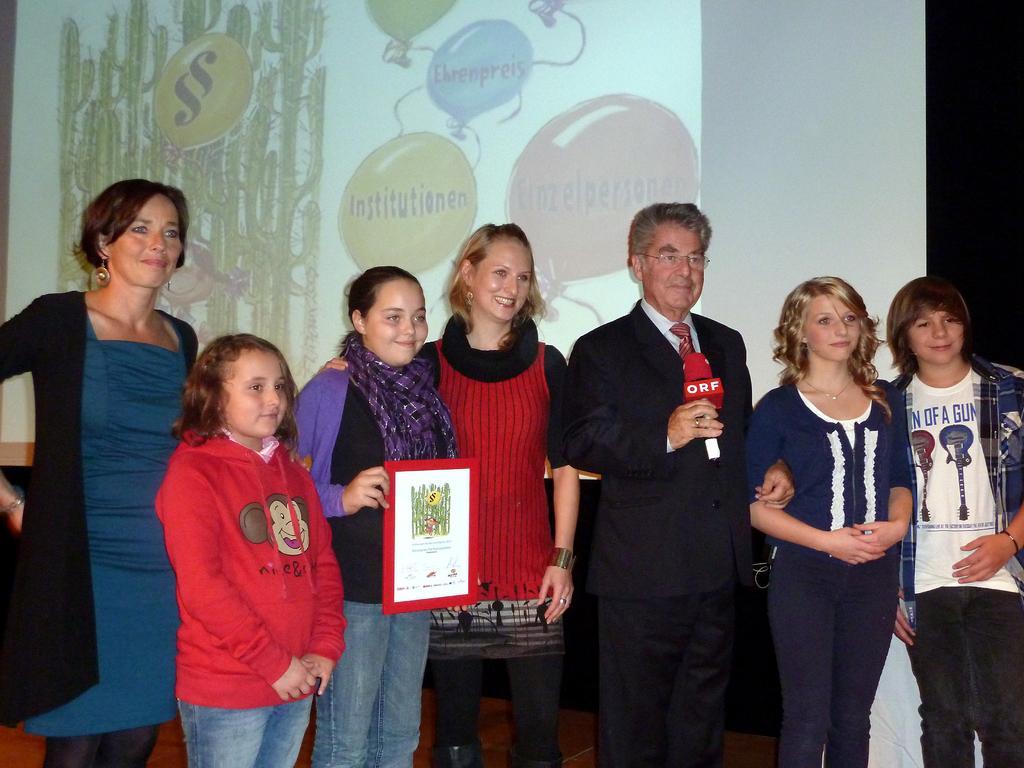How would you summarize this image in a sentence or two? At the bottom of this image, there are a person, women and children, smiling and standing on a stage. One of the children, holding a photo frame. In the background, there is a screen arranged. 